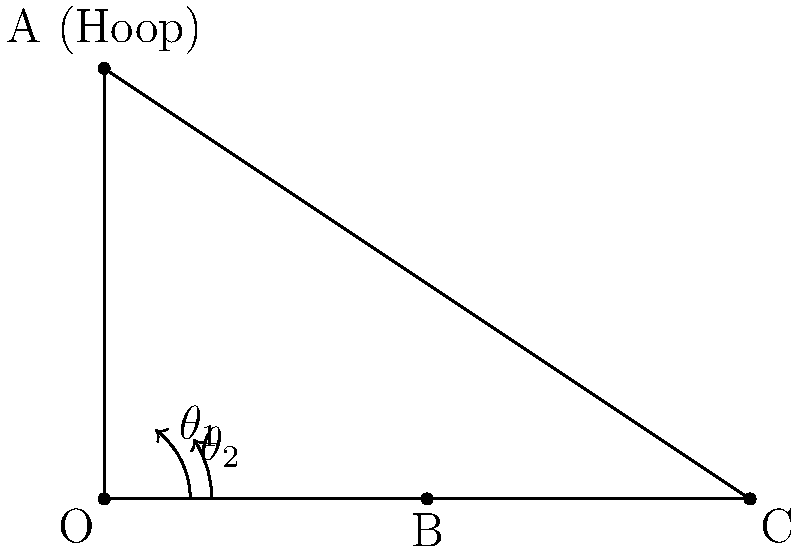At the Brattleboro High School gymnasium, you're practicing shots from different positions. From point B, 7.5 meters from the base of the hoop, you need to shoot at an angle of $\theta_1 = 53.1°$ for a successful basket. If you move to point C, which is twice as far from the base of the hoop as point B, what should be the new angle $\theta_2$ for a successful shot? Assume the hoop height remains constant at 10 meters. Let's approach this step-by-step:

1) First, we need to understand what the angles represent. $\theta_1$ and $\theta_2$ are the angles from the horizontal to the line of the shot.

2) For point B:
   - Distance from base = 7.5 m
   - Height of hoop = 10 m
   - $\tan(\theta_1) = \frac{\text{opposite}}{\text{adjacent}} = \frac{10}{7.5} = \frac{4}{3}$

3) For point C:
   - Distance from base = 15 m (twice as far as B)
   - Height of hoop = 10 m (remains constant)
   - We need to find $\theta_2$

4) We can use the tangent function again:
   $\tan(\theta_2) = \frac{\text{opposite}}{\text{adjacent}} = \frac{10}{15} = \frac{2}{3}$

5) To find $\theta_2$, we need to use the inverse tangent (arctangent) function:
   $\theta_2 = \arctan(\frac{2}{3})$

6) Using a calculator or computer:
   $\theta_2 \approx 33.7°$

Therefore, when shooting from point C, you should aim at an angle of approximately 33.7° from the horizontal for a successful basket.
Answer: $33.7°$ 